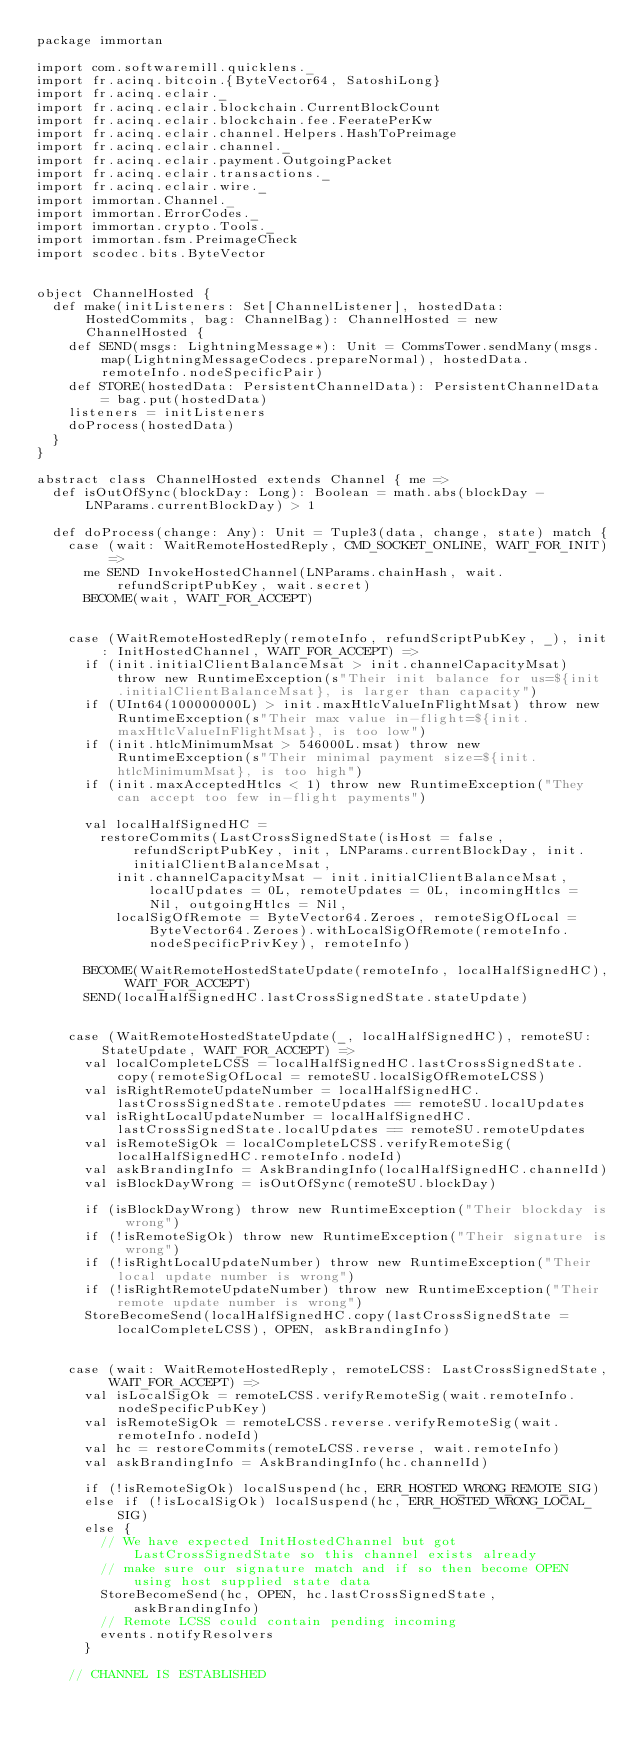Convert code to text. <code><loc_0><loc_0><loc_500><loc_500><_Scala_>package immortan

import com.softwaremill.quicklens._
import fr.acinq.bitcoin.{ByteVector64, SatoshiLong}
import fr.acinq.eclair._
import fr.acinq.eclair.blockchain.CurrentBlockCount
import fr.acinq.eclair.blockchain.fee.FeeratePerKw
import fr.acinq.eclair.channel.Helpers.HashToPreimage
import fr.acinq.eclair.channel._
import fr.acinq.eclair.payment.OutgoingPacket
import fr.acinq.eclair.transactions._
import fr.acinq.eclair.wire._
import immortan.Channel._
import immortan.ErrorCodes._
import immortan.crypto.Tools._
import immortan.fsm.PreimageCheck
import scodec.bits.ByteVector


object ChannelHosted {
  def make(initListeners: Set[ChannelListener], hostedData: HostedCommits, bag: ChannelBag): ChannelHosted = new ChannelHosted {
    def SEND(msgs: LightningMessage*): Unit = CommsTower.sendMany(msgs.map(LightningMessageCodecs.prepareNormal), hostedData.remoteInfo.nodeSpecificPair)
    def STORE(hostedData: PersistentChannelData): PersistentChannelData = bag.put(hostedData)
    listeners = initListeners
    doProcess(hostedData)
  }
}

abstract class ChannelHosted extends Channel { me =>
  def isOutOfSync(blockDay: Long): Boolean = math.abs(blockDay - LNParams.currentBlockDay) > 1

  def doProcess(change: Any): Unit = Tuple3(data, change, state) match {
    case (wait: WaitRemoteHostedReply, CMD_SOCKET_ONLINE, WAIT_FOR_INIT) =>
      me SEND InvokeHostedChannel(LNParams.chainHash, wait.refundScriptPubKey, wait.secret)
      BECOME(wait, WAIT_FOR_ACCEPT)


    case (WaitRemoteHostedReply(remoteInfo, refundScriptPubKey, _), init: InitHostedChannel, WAIT_FOR_ACCEPT) =>
      if (init.initialClientBalanceMsat > init.channelCapacityMsat) throw new RuntimeException(s"Their init balance for us=${init.initialClientBalanceMsat}, is larger than capacity")
      if (UInt64(100000000L) > init.maxHtlcValueInFlightMsat) throw new RuntimeException(s"Their max value in-flight=${init.maxHtlcValueInFlightMsat}, is too low")
      if (init.htlcMinimumMsat > 546000L.msat) throw new RuntimeException(s"Their minimal payment size=${init.htlcMinimumMsat}, is too high")
      if (init.maxAcceptedHtlcs < 1) throw new RuntimeException("They can accept too few in-flight payments")

      val localHalfSignedHC =
        restoreCommits(LastCrossSignedState(isHost = false, refundScriptPubKey, init, LNParams.currentBlockDay, init.initialClientBalanceMsat,
          init.channelCapacityMsat - init.initialClientBalanceMsat, localUpdates = 0L, remoteUpdates = 0L, incomingHtlcs = Nil, outgoingHtlcs = Nil,
          localSigOfRemote = ByteVector64.Zeroes, remoteSigOfLocal = ByteVector64.Zeroes).withLocalSigOfRemote(remoteInfo.nodeSpecificPrivKey), remoteInfo)

      BECOME(WaitRemoteHostedStateUpdate(remoteInfo, localHalfSignedHC), WAIT_FOR_ACCEPT)
      SEND(localHalfSignedHC.lastCrossSignedState.stateUpdate)


    case (WaitRemoteHostedStateUpdate(_, localHalfSignedHC), remoteSU: StateUpdate, WAIT_FOR_ACCEPT) =>
      val localCompleteLCSS = localHalfSignedHC.lastCrossSignedState.copy(remoteSigOfLocal = remoteSU.localSigOfRemoteLCSS)
      val isRightRemoteUpdateNumber = localHalfSignedHC.lastCrossSignedState.remoteUpdates == remoteSU.localUpdates
      val isRightLocalUpdateNumber = localHalfSignedHC.lastCrossSignedState.localUpdates == remoteSU.remoteUpdates
      val isRemoteSigOk = localCompleteLCSS.verifyRemoteSig(localHalfSignedHC.remoteInfo.nodeId)
      val askBrandingInfo = AskBrandingInfo(localHalfSignedHC.channelId)
      val isBlockDayWrong = isOutOfSync(remoteSU.blockDay)

      if (isBlockDayWrong) throw new RuntimeException("Their blockday is wrong")
      if (!isRemoteSigOk) throw new RuntimeException("Their signature is wrong")
      if (!isRightLocalUpdateNumber) throw new RuntimeException("Their local update number is wrong")
      if (!isRightRemoteUpdateNumber) throw new RuntimeException("Their remote update number is wrong")
      StoreBecomeSend(localHalfSignedHC.copy(lastCrossSignedState = localCompleteLCSS), OPEN, askBrandingInfo)


    case (wait: WaitRemoteHostedReply, remoteLCSS: LastCrossSignedState, WAIT_FOR_ACCEPT) =>
      val isLocalSigOk = remoteLCSS.verifyRemoteSig(wait.remoteInfo.nodeSpecificPubKey)
      val isRemoteSigOk = remoteLCSS.reverse.verifyRemoteSig(wait.remoteInfo.nodeId)
      val hc = restoreCommits(remoteLCSS.reverse, wait.remoteInfo)
      val askBrandingInfo = AskBrandingInfo(hc.channelId)

      if (!isRemoteSigOk) localSuspend(hc, ERR_HOSTED_WRONG_REMOTE_SIG)
      else if (!isLocalSigOk) localSuspend(hc, ERR_HOSTED_WRONG_LOCAL_SIG)
      else {
        // We have expected InitHostedChannel but got LastCrossSignedState so this channel exists already
        // make sure our signature match and if so then become OPEN using host supplied state data
        StoreBecomeSend(hc, OPEN, hc.lastCrossSignedState, askBrandingInfo)
        // Remote LCSS could contain pending incoming
        events.notifyResolvers
      }

    // CHANNEL IS ESTABLISHED
</code> 